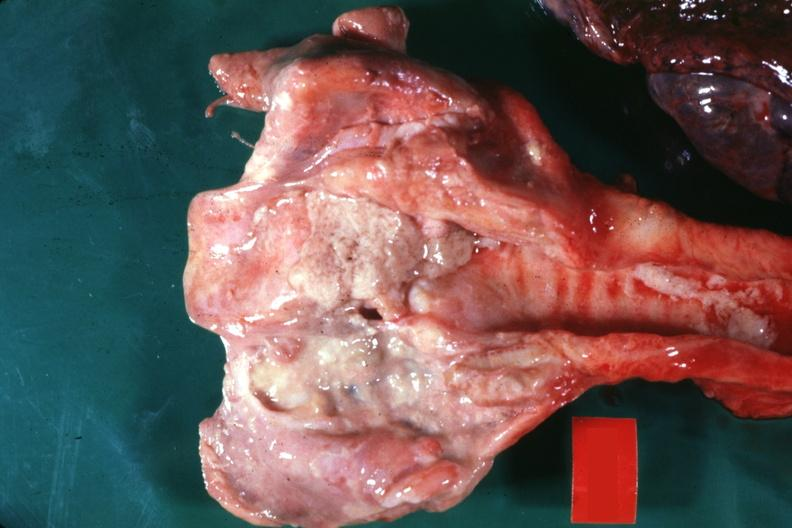does malignant adenoma show large ulcers probably secondary to tube?
Answer the question using a single word or phrase. No 